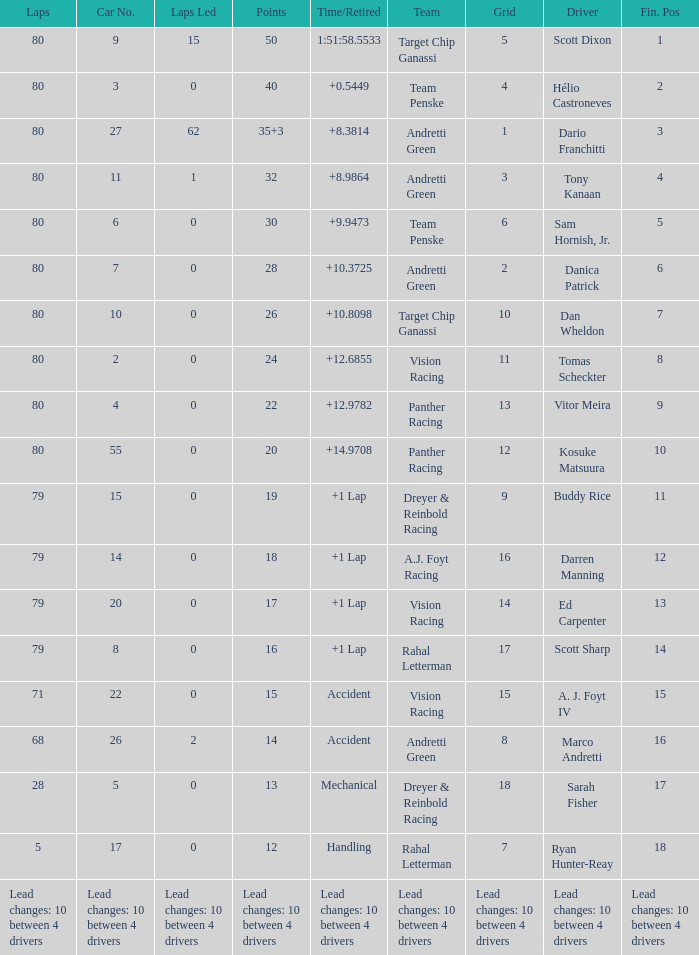How many laps does driver dario franchitti have? 80.0. 